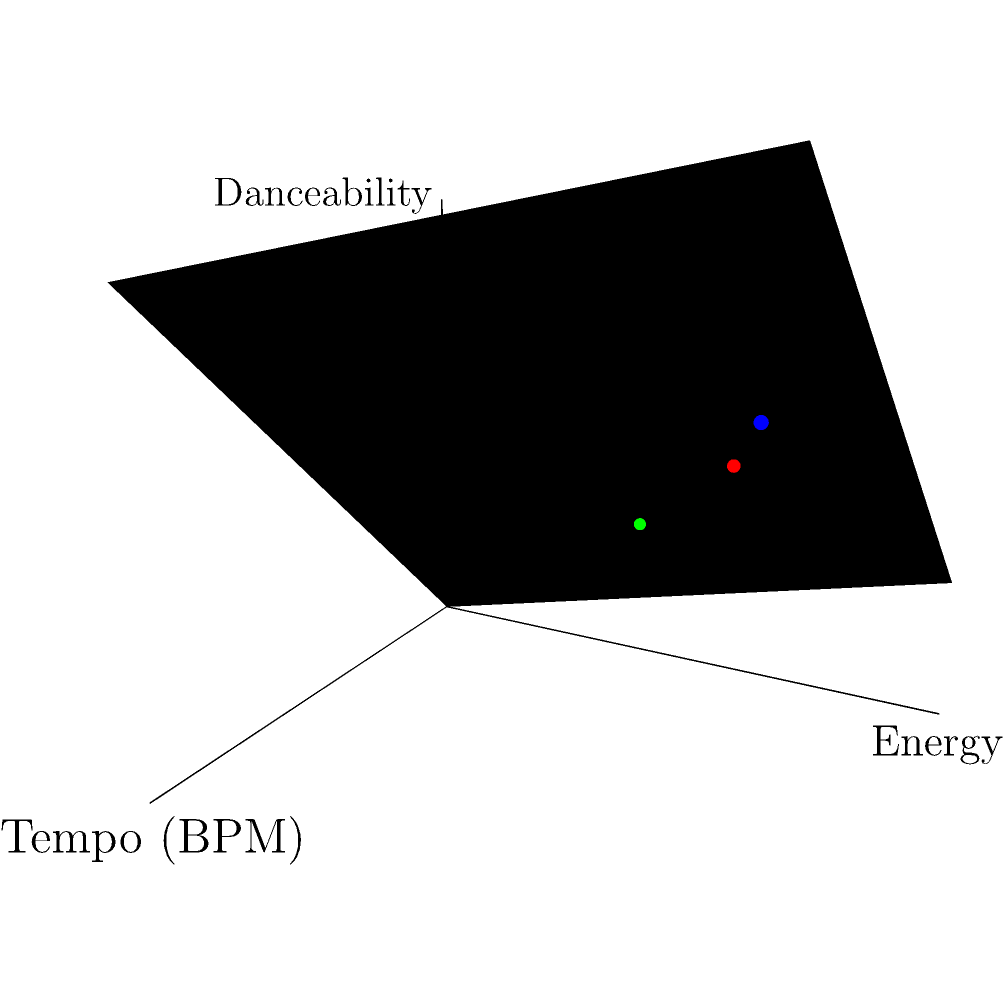In the 3D coordinate system shown, points A, B, and C represent three different songs on a dining playlist. The x-axis represents tempo (BPM), the y-axis represents energy, and the z-axis represents danceability. Which song would be most suitable for the main course of a high-energy dinner party? To determine which song is most suitable for the main course of a high-energy dinner party, we need to analyze the characteristics of each song represented by points A, B, and C:

1. Point A (120 BPM, 80 energy, 70 danceability):
   - Moderate tempo
   - High energy
   - Good danceability

2. Point B (160 BPM, 90 energy, 85 danceability):
   - Fast tempo
   - Very high energy
   - High danceability

3. Point C (90 BPM, 60 energy, 50 danceability):
   - Slower tempo
   - Moderate energy
   - Lower danceability

For a high-energy dinner party, we want a song that has:
- A fast tempo to keep the energy up
- High energy to match the party atmosphere
- Good danceability to encourage movement and interaction

Comparing the three songs:
- Song B has the highest values in all three categories
- Song A is second in all categories
- Song C has the lowest values in all categories

Therefore, Song B (represented by point B) would be the most suitable for the main course of a high-energy dinner party. Its fast tempo, very high energy, and high danceability make it perfect for maintaining an upbeat atmosphere during the main part of the event.
Answer: Song B (Point B) 